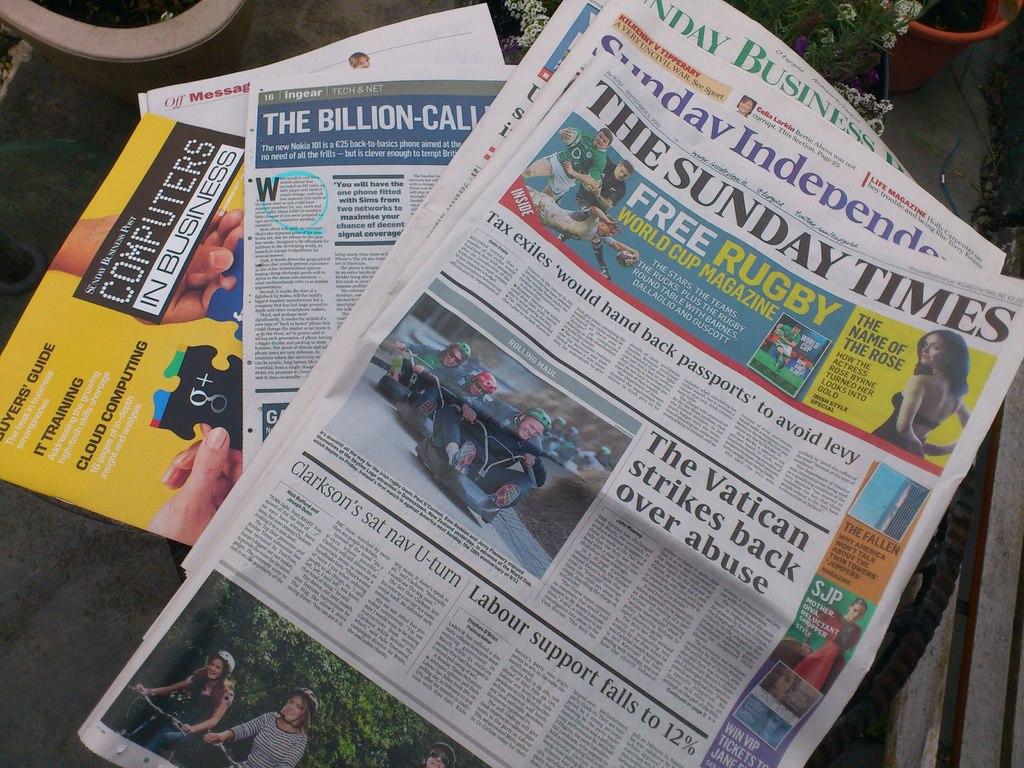Who is striking back over abuse?
Provide a short and direct response. The vatican. What is this paper on the table?
Give a very brief answer. The sunday times. 